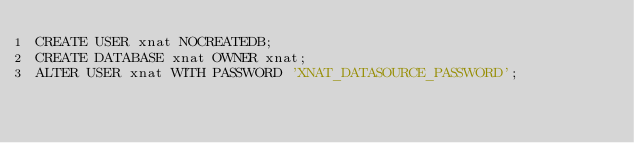Convert code to text. <code><loc_0><loc_0><loc_500><loc_500><_SQL_>CREATE USER xnat NOCREATEDB;
CREATE DATABASE xnat OWNER xnat;
ALTER USER xnat WITH PASSWORD 'XNAT_DATASOURCE_PASSWORD';
</code> 